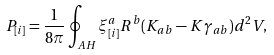Convert formula to latex. <formula><loc_0><loc_0><loc_500><loc_500>P _ { [ i ] } = \frac { 1 } { 8 \pi } \oint _ { A H } \xi ^ { a } _ { [ i ] } R ^ { b } ( K _ { a b } - K \gamma _ { a b } ) d ^ { 2 } V ,</formula> 